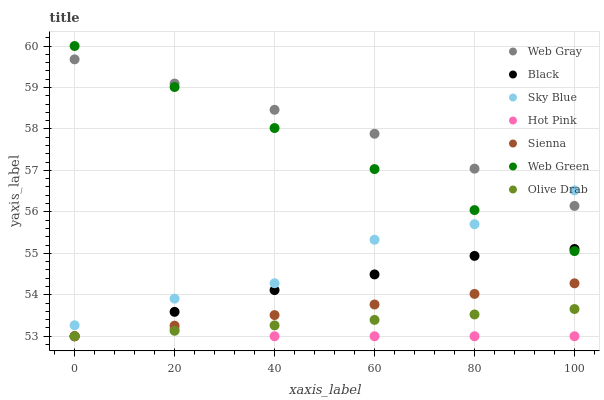Does Hot Pink have the minimum area under the curve?
Answer yes or no. Yes. Does Web Gray have the maximum area under the curve?
Answer yes or no. Yes. Does Web Green have the minimum area under the curve?
Answer yes or no. No. Does Web Green have the maximum area under the curve?
Answer yes or no. No. Is Web Green the smoothest?
Answer yes or no. Yes. Is Sky Blue the roughest?
Answer yes or no. Yes. Is Hot Pink the smoothest?
Answer yes or no. No. Is Hot Pink the roughest?
Answer yes or no. No. Does Hot Pink have the lowest value?
Answer yes or no. Yes. Does Web Green have the lowest value?
Answer yes or no. No. Does Web Green have the highest value?
Answer yes or no. Yes. Does Hot Pink have the highest value?
Answer yes or no. No. Is Sienna less than Black?
Answer yes or no. Yes. Is Web Gray greater than Black?
Answer yes or no. Yes. Does Olive Drab intersect Hot Pink?
Answer yes or no. Yes. Is Olive Drab less than Hot Pink?
Answer yes or no. No. Is Olive Drab greater than Hot Pink?
Answer yes or no. No. Does Sienna intersect Black?
Answer yes or no. No. 